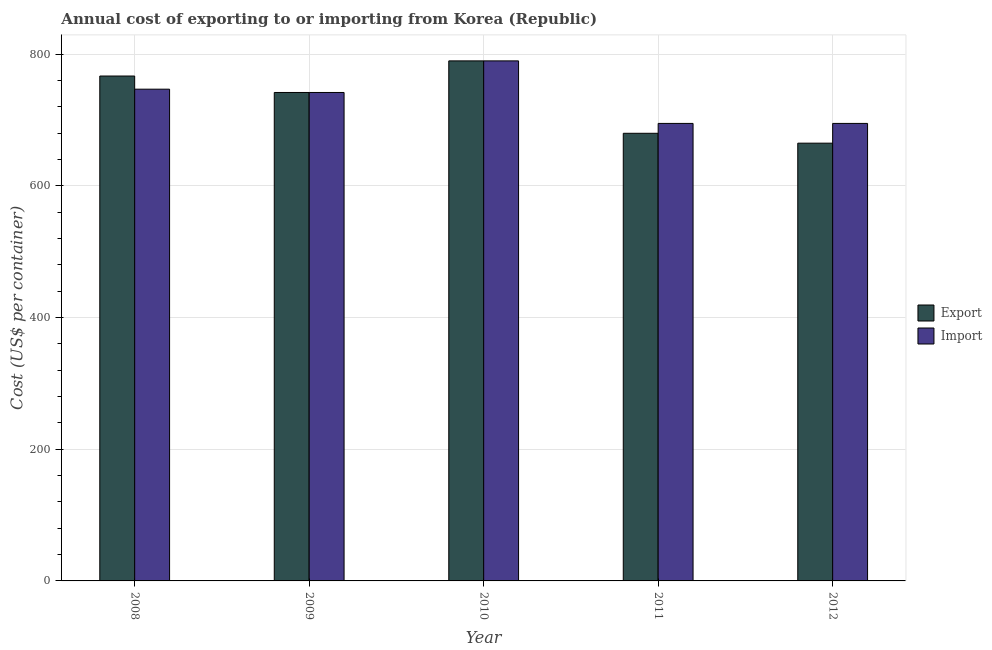How many different coloured bars are there?
Provide a succinct answer. 2. How many groups of bars are there?
Your response must be concise. 5. How many bars are there on the 3rd tick from the left?
Offer a very short reply. 2. How many bars are there on the 5th tick from the right?
Keep it short and to the point. 2. What is the label of the 4th group of bars from the left?
Give a very brief answer. 2011. In how many cases, is the number of bars for a given year not equal to the number of legend labels?
Provide a short and direct response. 0. What is the import cost in 2011?
Provide a succinct answer. 695. Across all years, what is the maximum export cost?
Offer a very short reply. 790. Across all years, what is the minimum export cost?
Ensure brevity in your answer.  665. In which year was the import cost maximum?
Give a very brief answer. 2010. What is the total export cost in the graph?
Give a very brief answer. 3644. What is the difference between the export cost in 2009 and that in 2011?
Ensure brevity in your answer.  62. What is the difference between the import cost in 2012 and the export cost in 2008?
Give a very brief answer. -52. What is the average export cost per year?
Make the answer very short. 728.8. In how many years, is the export cost greater than 600 US$?
Make the answer very short. 5. What is the ratio of the import cost in 2010 to that in 2011?
Ensure brevity in your answer.  1.14. Is the difference between the export cost in 2008 and 2012 greater than the difference between the import cost in 2008 and 2012?
Give a very brief answer. No. What is the difference between the highest and the lowest import cost?
Ensure brevity in your answer.  95. Is the sum of the import cost in 2008 and 2010 greater than the maximum export cost across all years?
Offer a terse response. Yes. What does the 2nd bar from the left in 2008 represents?
Your answer should be very brief. Import. What does the 1st bar from the right in 2010 represents?
Keep it short and to the point. Import. Are all the bars in the graph horizontal?
Your answer should be very brief. No. How many years are there in the graph?
Make the answer very short. 5. What is the difference between two consecutive major ticks on the Y-axis?
Provide a short and direct response. 200. Does the graph contain any zero values?
Provide a short and direct response. No. What is the title of the graph?
Keep it short and to the point. Annual cost of exporting to or importing from Korea (Republic). What is the label or title of the Y-axis?
Your answer should be very brief. Cost (US$ per container). What is the Cost (US$ per container) of Export in 2008?
Offer a very short reply. 767. What is the Cost (US$ per container) of Import in 2008?
Provide a short and direct response. 747. What is the Cost (US$ per container) of Export in 2009?
Your response must be concise. 742. What is the Cost (US$ per container) of Import in 2009?
Provide a succinct answer. 742. What is the Cost (US$ per container) in Export in 2010?
Offer a terse response. 790. What is the Cost (US$ per container) of Import in 2010?
Provide a succinct answer. 790. What is the Cost (US$ per container) in Export in 2011?
Make the answer very short. 680. What is the Cost (US$ per container) of Import in 2011?
Give a very brief answer. 695. What is the Cost (US$ per container) of Export in 2012?
Keep it short and to the point. 665. What is the Cost (US$ per container) of Import in 2012?
Offer a very short reply. 695. Across all years, what is the maximum Cost (US$ per container) of Export?
Keep it short and to the point. 790. Across all years, what is the maximum Cost (US$ per container) of Import?
Ensure brevity in your answer.  790. Across all years, what is the minimum Cost (US$ per container) in Export?
Provide a short and direct response. 665. Across all years, what is the minimum Cost (US$ per container) in Import?
Your answer should be compact. 695. What is the total Cost (US$ per container) in Export in the graph?
Provide a short and direct response. 3644. What is the total Cost (US$ per container) of Import in the graph?
Keep it short and to the point. 3669. What is the difference between the Cost (US$ per container) of Export in 2008 and that in 2010?
Your response must be concise. -23. What is the difference between the Cost (US$ per container) in Import in 2008 and that in 2010?
Give a very brief answer. -43. What is the difference between the Cost (US$ per container) of Export in 2008 and that in 2011?
Give a very brief answer. 87. What is the difference between the Cost (US$ per container) of Import in 2008 and that in 2011?
Your answer should be compact. 52. What is the difference between the Cost (US$ per container) in Export in 2008 and that in 2012?
Provide a short and direct response. 102. What is the difference between the Cost (US$ per container) in Import in 2008 and that in 2012?
Your response must be concise. 52. What is the difference between the Cost (US$ per container) of Export in 2009 and that in 2010?
Your response must be concise. -48. What is the difference between the Cost (US$ per container) of Import in 2009 and that in 2010?
Give a very brief answer. -48. What is the difference between the Cost (US$ per container) in Export in 2009 and that in 2012?
Your answer should be compact. 77. What is the difference between the Cost (US$ per container) of Export in 2010 and that in 2011?
Ensure brevity in your answer.  110. What is the difference between the Cost (US$ per container) of Export in 2010 and that in 2012?
Offer a very short reply. 125. What is the difference between the Cost (US$ per container) of Export in 2011 and that in 2012?
Your answer should be compact. 15. What is the difference between the Cost (US$ per container) in Import in 2011 and that in 2012?
Give a very brief answer. 0. What is the difference between the Cost (US$ per container) in Export in 2008 and the Cost (US$ per container) in Import in 2009?
Offer a terse response. 25. What is the difference between the Cost (US$ per container) of Export in 2008 and the Cost (US$ per container) of Import in 2010?
Provide a short and direct response. -23. What is the difference between the Cost (US$ per container) of Export in 2008 and the Cost (US$ per container) of Import in 2011?
Provide a short and direct response. 72. What is the difference between the Cost (US$ per container) of Export in 2008 and the Cost (US$ per container) of Import in 2012?
Your answer should be compact. 72. What is the difference between the Cost (US$ per container) of Export in 2009 and the Cost (US$ per container) of Import in 2010?
Ensure brevity in your answer.  -48. What is the difference between the Cost (US$ per container) of Export in 2009 and the Cost (US$ per container) of Import in 2011?
Your answer should be compact. 47. What is the difference between the Cost (US$ per container) in Export in 2009 and the Cost (US$ per container) in Import in 2012?
Your answer should be very brief. 47. What is the difference between the Cost (US$ per container) in Export in 2010 and the Cost (US$ per container) in Import in 2012?
Ensure brevity in your answer.  95. What is the average Cost (US$ per container) of Export per year?
Your answer should be compact. 728.8. What is the average Cost (US$ per container) in Import per year?
Your answer should be compact. 733.8. In the year 2012, what is the difference between the Cost (US$ per container) in Export and Cost (US$ per container) in Import?
Keep it short and to the point. -30. What is the ratio of the Cost (US$ per container) of Export in 2008 to that in 2009?
Provide a succinct answer. 1.03. What is the ratio of the Cost (US$ per container) of Export in 2008 to that in 2010?
Give a very brief answer. 0.97. What is the ratio of the Cost (US$ per container) of Import in 2008 to that in 2010?
Offer a very short reply. 0.95. What is the ratio of the Cost (US$ per container) of Export in 2008 to that in 2011?
Your answer should be very brief. 1.13. What is the ratio of the Cost (US$ per container) of Import in 2008 to that in 2011?
Offer a very short reply. 1.07. What is the ratio of the Cost (US$ per container) of Export in 2008 to that in 2012?
Ensure brevity in your answer.  1.15. What is the ratio of the Cost (US$ per container) of Import in 2008 to that in 2012?
Your answer should be compact. 1.07. What is the ratio of the Cost (US$ per container) in Export in 2009 to that in 2010?
Give a very brief answer. 0.94. What is the ratio of the Cost (US$ per container) of Import in 2009 to that in 2010?
Provide a succinct answer. 0.94. What is the ratio of the Cost (US$ per container) of Export in 2009 to that in 2011?
Give a very brief answer. 1.09. What is the ratio of the Cost (US$ per container) in Import in 2009 to that in 2011?
Offer a terse response. 1.07. What is the ratio of the Cost (US$ per container) of Export in 2009 to that in 2012?
Your answer should be compact. 1.12. What is the ratio of the Cost (US$ per container) of Import in 2009 to that in 2012?
Keep it short and to the point. 1.07. What is the ratio of the Cost (US$ per container) in Export in 2010 to that in 2011?
Offer a terse response. 1.16. What is the ratio of the Cost (US$ per container) of Import in 2010 to that in 2011?
Your answer should be compact. 1.14. What is the ratio of the Cost (US$ per container) in Export in 2010 to that in 2012?
Provide a short and direct response. 1.19. What is the ratio of the Cost (US$ per container) of Import in 2010 to that in 2012?
Keep it short and to the point. 1.14. What is the ratio of the Cost (US$ per container) of Export in 2011 to that in 2012?
Provide a succinct answer. 1.02. What is the ratio of the Cost (US$ per container) in Import in 2011 to that in 2012?
Offer a very short reply. 1. What is the difference between the highest and the second highest Cost (US$ per container) in Import?
Provide a short and direct response. 43. What is the difference between the highest and the lowest Cost (US$ per container) in Export?
Offer a terse response. 125. 